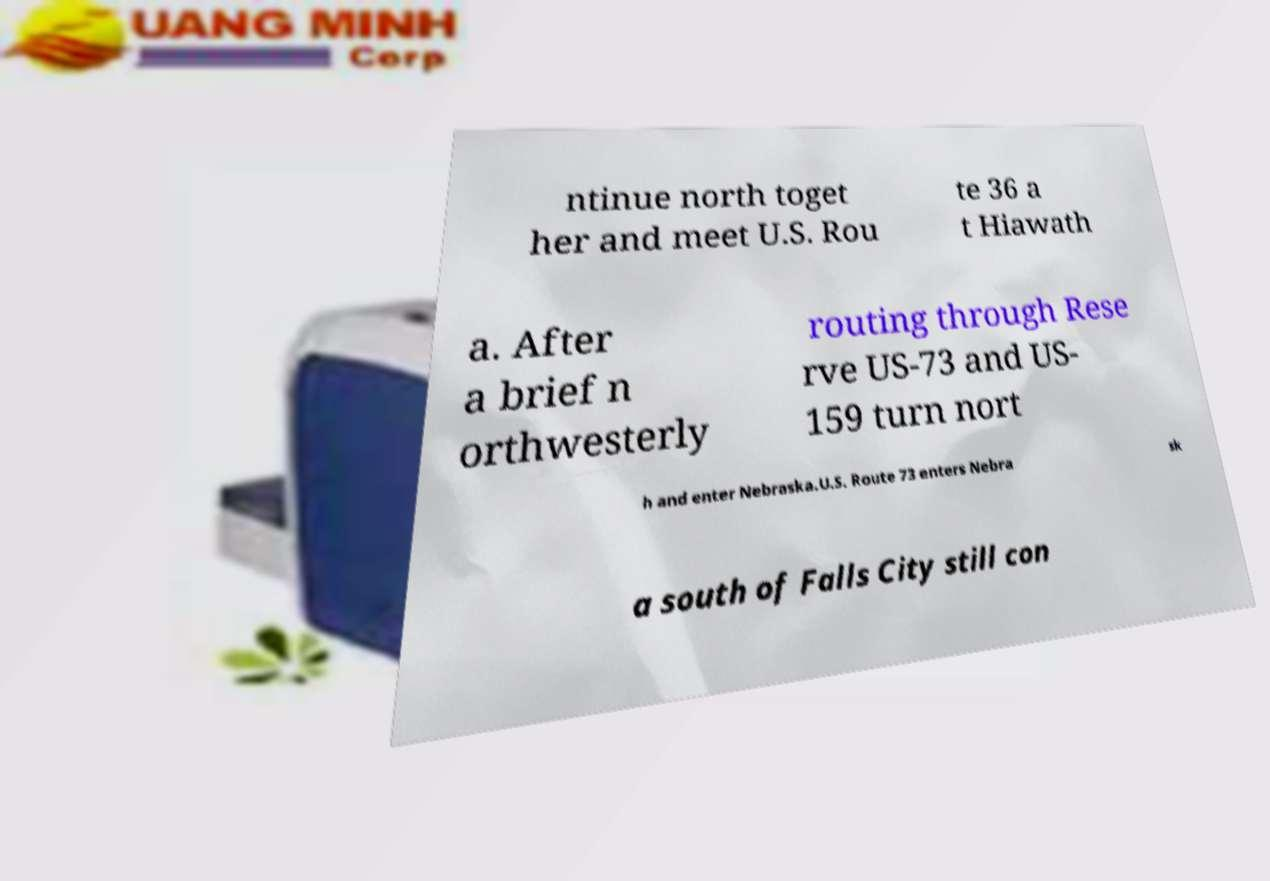Can you accurately transcribe the text from the provided image for me? ntinue north toget her and meet U.S. Rou te 36 a t Hiawath a. After a brief n orthwesterly routing through Rese rve US-73 and US- 159 turn nort h and enter Nebraska.U.S. Route 73 enters Nebra sk a south of Falls City still con 